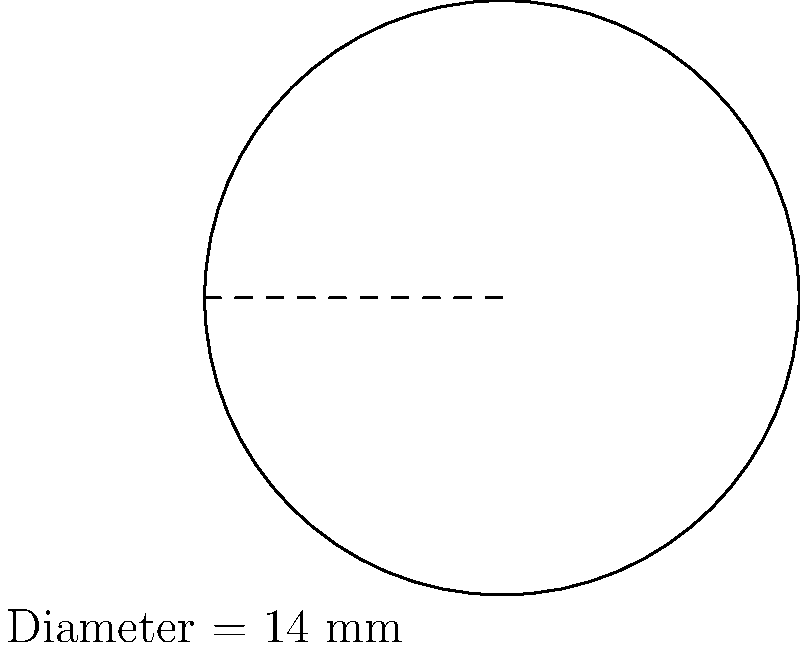A new type of contact lens has been developed for patients with astigmatism. The lens has a diameter of 14 mm. Calculate the surface area of the lens that will be in contact with the eye. Round your answer to the nearest square millimeter. To solve this problem, we need to follow these steps:

1) First, recall the formula for the area of a circle:
   $$A = \pi r^2$$
   where $A$ is the area and $r$ is the radius.

2) We are given the diameter, which is 14 mm. The radius is half of the diameter:
   $$r = \frac{14}{2} = 7 \text{ mm}$$

3) Now we can substitute this into our area formula:
   $$A = \pi (7 \text{ mm})^2$$

4) Simplify:
   $$A = 49\pi \text{ mm}^2$$

5) Use 3.14159 as an approximation for $\pi$:
   $$A \approx 49 \times 3.14159 \text{ mm}^2 = 153.93791 \text{ mm}^2$$

6) Rounding to the nearest square millimeter:
   $$A \approx 154 \text{ mm}^2$$
Answer: 154 mm² 